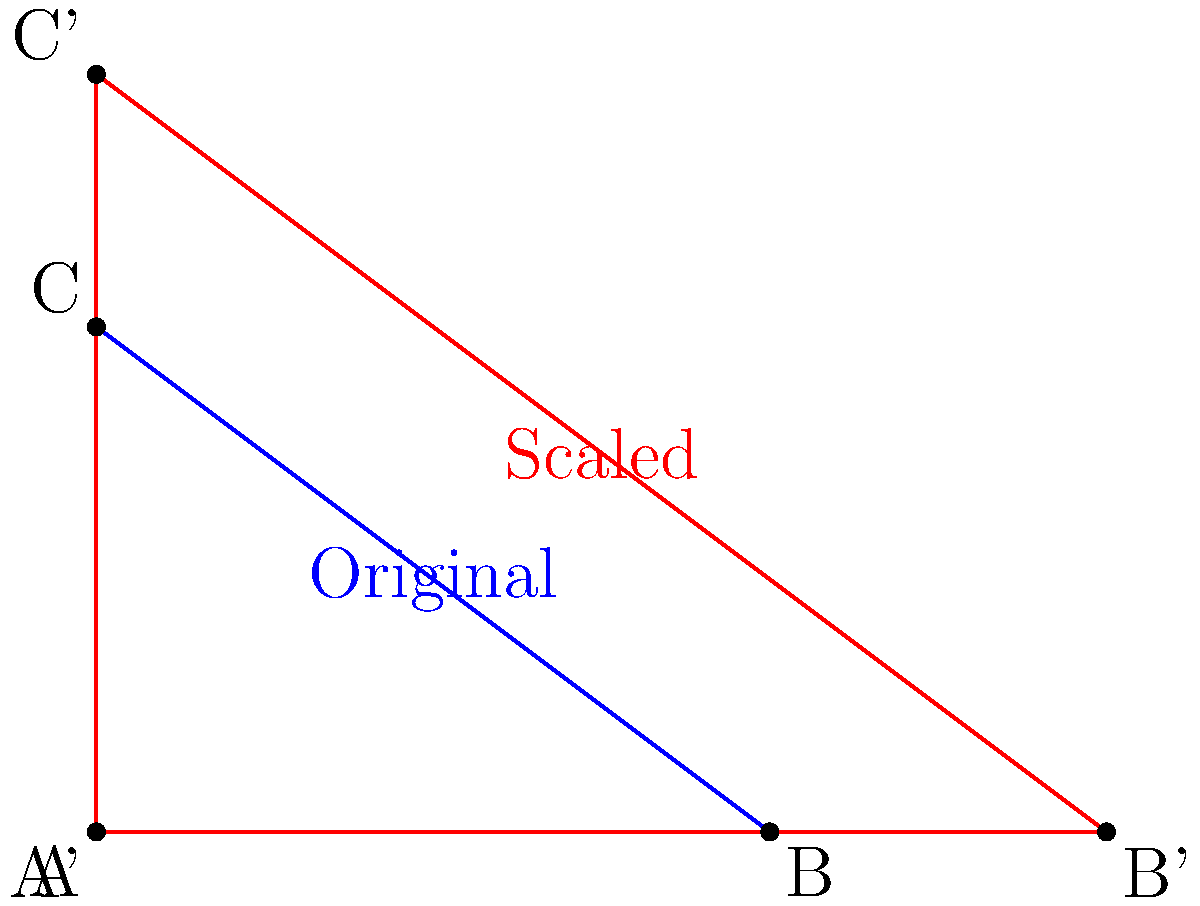In your geometry class, you're given a triangle ABC with a base of 4 units and a height of 3 units. You decide to scale this triangle by a factor of 1.5 to create a new triangle A'B'C'. How many times larger is the area of the new triangle compared to the original? Let's approach this step-by-step:

1) First, we need to calculate the area of the original triangle ABC.
   Area of a triangle = $\frac{1}{2} \times base \times height$
   $A_{original} = \frac{1}{2} \times 4 \times 3 = 6$ square units

2) Now, let's consider what happens when we scale by a factor of 1.5:
   - The base becomes $4 \times 1.5 = 6$ units
   - The height becomes $3 \times 1.5 = 4.5$ units

3) We can calculate the area of the new triangle A'B'C':
   $A_{new} = \frac{1}{2} \times 6 \times 4.5 = 13.5$ square units

4) To find how many times larger the new area is, we divide:
   $\frac{A_{new}}{A_{original}} = \frac{13.5}{6} = 2.25$

5) We can also derive this result directly from the scale factor:
   When we scale a 2D figure by a factor of k, its area increases by a factor of $k^2$.
   In this case, $k = 1.5$, so the area increase is $1.5^2 = 2.25$

Therefore, the area of the new triangle is 2.25 times larger than the original.
Answer: 2.25 times larger 